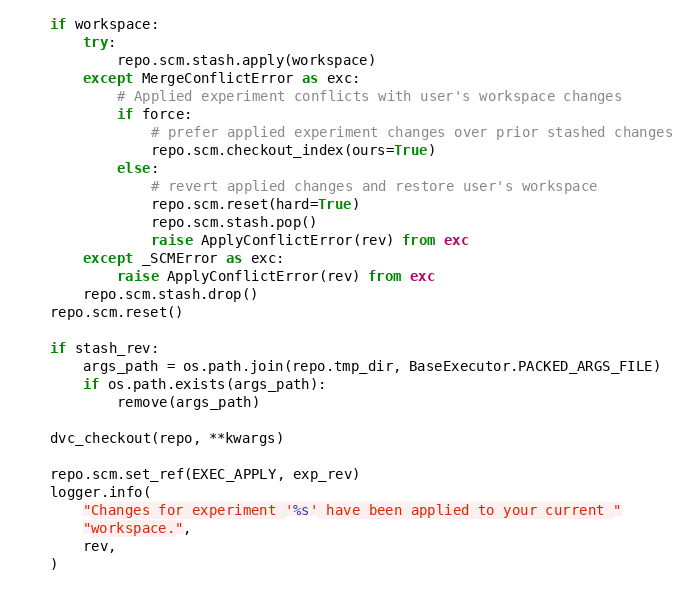Convert code to text. <code><loc_0><loc_0><loc_500><loc_500><_Python_>
    if workspace:
        try:
            repo.scm.stash.apply(workspace)
        except MergeConflictError as exc:
            # Applied experiment conflicts with user's workspace changes
            if force:
                # prefer applied experiment changes over prior stashed changes
                repo.scm.checkout_index(ours=True)
            else:
                # revert applied changes and restore user's workspace
                repo.scm.reset(hard=True)
                repo.scm.stash.pop()
                raise ApplyConflictError(rev) from exc
        except _SCMError as exc:
            raise ApplyConflictError(rev) from exc
        repo.scm.stash.drop()
    repo.scm.reset()

    if stash_rev:
        args_path = os.path.join(repo.tmp_dir, BaseExecutor.PACKED_ARGS_FILE)
        if os.path.exists(args_path):
            remove(args_path)

    dvc_checkout(repo, **kwargs)

    repo.scm.set_ref(EXEC_APPLY, exp_rev)
    logger.info(
        "Changes for experiment '%s' have been applied to your current "
        "workspace.",
        rev,
    )
</code> 